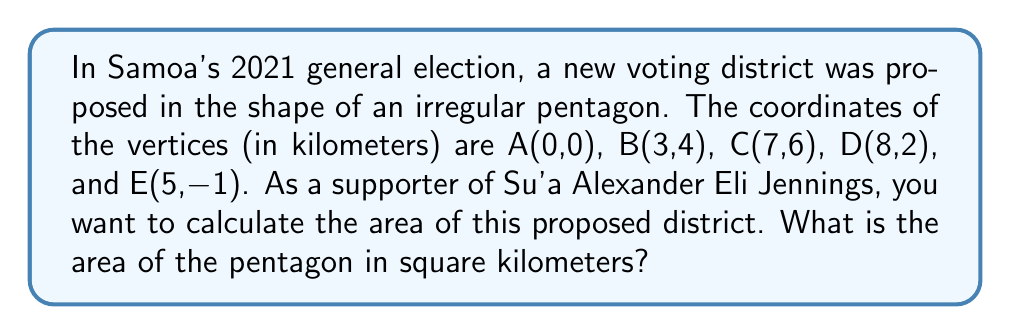Show me your answer to this math problem. To calculate the area of an irregular pentagon given its vertices, we can use the Shoelace formula (also known as the surveyor's formula). The steps are as follows:

1) List the coordinates in order (either clockwise or counterclockwise), repeating the first coordinate at the end:
   $(x_1,y_1), (x_2,y_2), (x_3,y_3), (x_4,y_4), (x_5,y_5), (x_1,y_1)$

2) Apply the formula:
   $$A = \frac{1}{2}|(x_1y_2 + x_2y_3 + x_3y_4 + x_4y_5 + x_5y_1) - (y_1x_2 + y_2x_3 + y_3x_4 + y_4x_5 + y_5x_1)|$$

3) Substitute the given coordinates:
   A(0,0), B(3,4), C(7,6), D(8,2), E(5,-1), A(0,0)

4) Calculate:
   $$A = \frac{1}{2}|(0\cdot4 + 3\cdot6 + 7\cdot2 + 8\cdot(-1) + 5\cdot0) - (0\cdot3 + 4\cdot7 + 6\cdot8 + 2\cdot5 + (-1)\cdot0)|$$
   $$A = \frac{1}{2}|(0 + 18 + 14 - 8 + 0) - (0 + 28 + 48 + 10 + 0)|$$
   $$A = \frac{1}{2}|24 - 86|$$
   $$A = \frac{1}{2}|-62|$$
   $$A = \frac{62}{2} = 31$$

Therefore, the area of the proposed voting district is 31 square kilometers.
Answer: 31 km² 